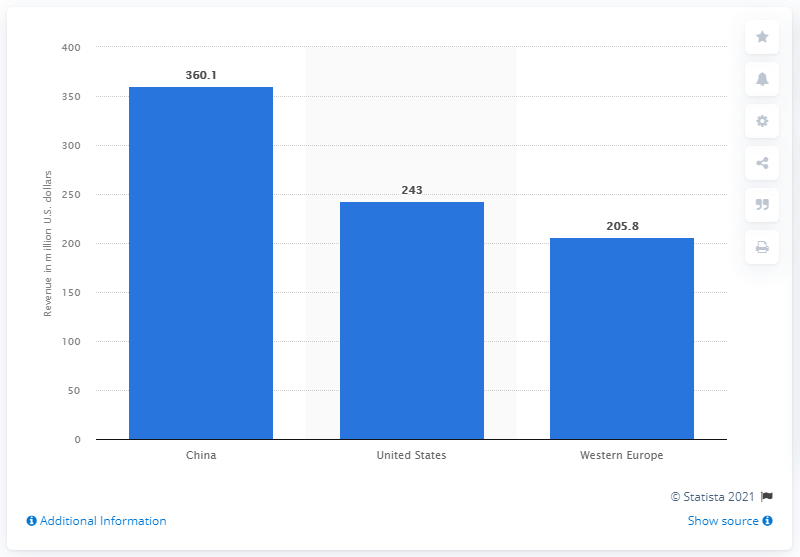Give some essential details in this illustration. In 2021, China was the largest eSports market worldwide. In 2021, China generated approximately 360.1 billion dollars in the eSports industry. 